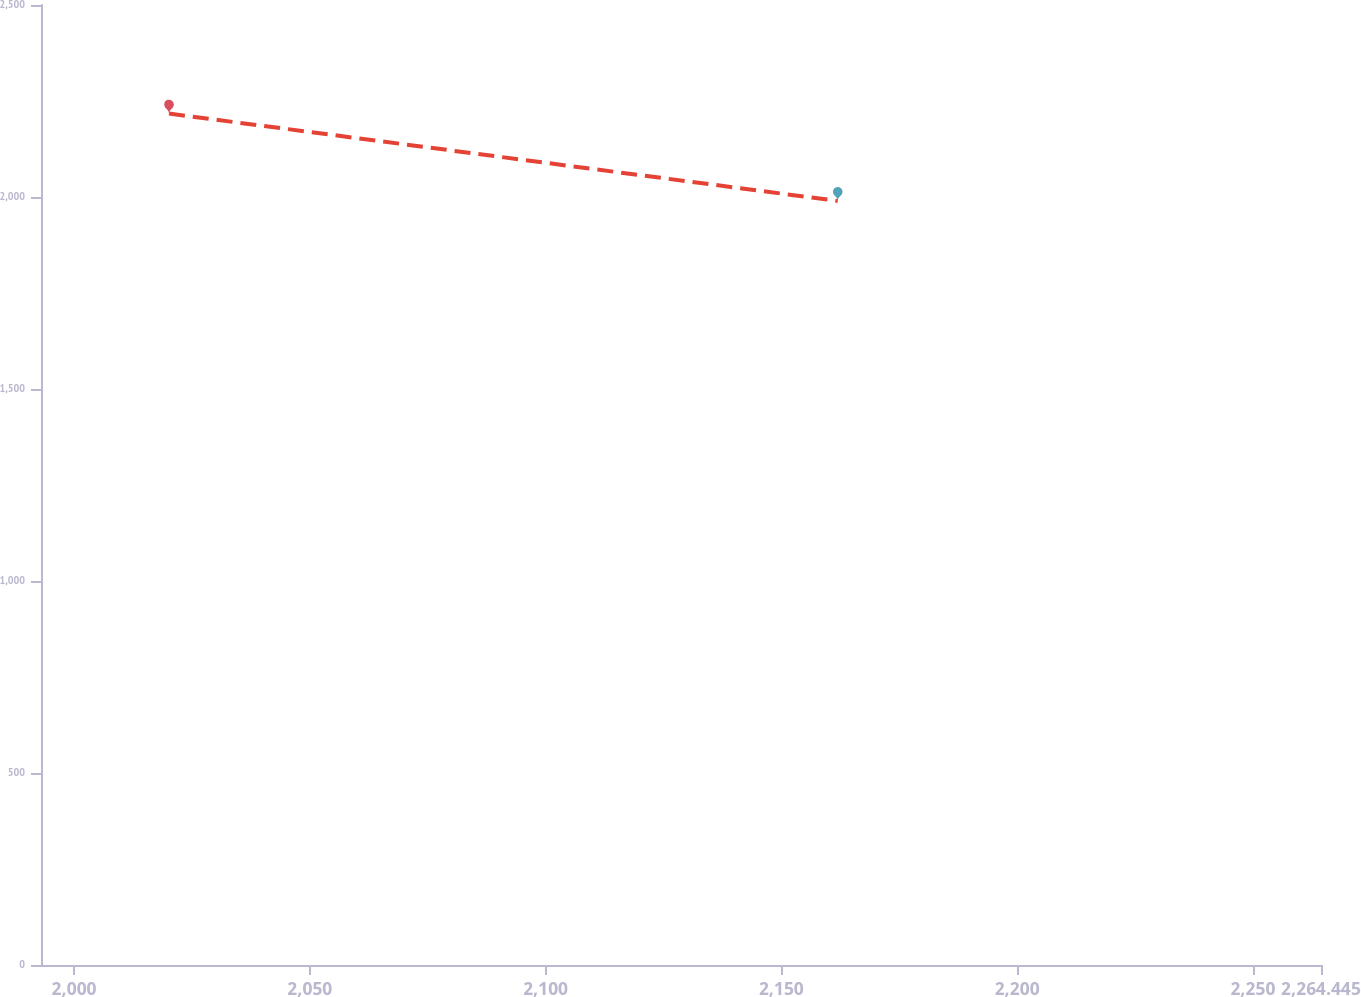Convert chart. <chart><loc_0><loc_0><loc_500><loc_500><line_chart><ecel><fcel>Unnamed: 1<nl><fcel>2020.14<fcel>2217.21<nl><fcel>2161.96<fcel>1989.74<nl><fcel>2291.59<fcel>2108.57<nl></chart> 